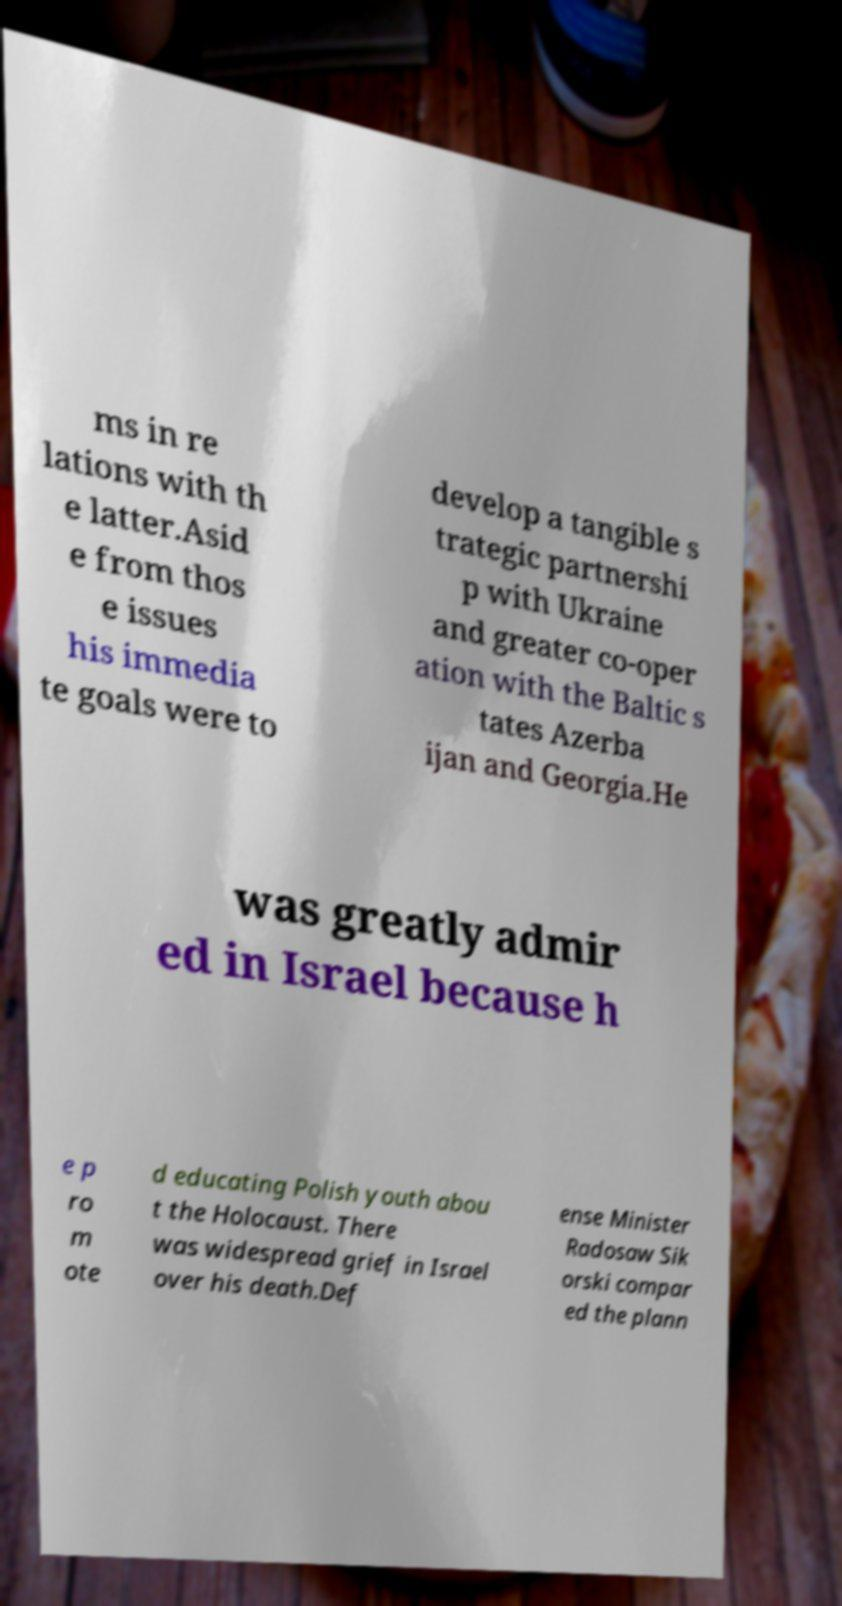Can you accurately transcribe the text from the provided image for me? ms in re lations with th e latter.Asid e from thos e issues his immedia te goals were to develop a tangible s trategic partnershi p with Ukraine and greater co-oper ation with the Baltic s tates Azerba ijan and Georgia.He was greatly admir ed in Israel because h e p ro m ote d educating Polish youth abou t the Holocaust. There was widespread grief in Israel over his death.Def ense Minister Radosaw Sik orski compar ed the plann 